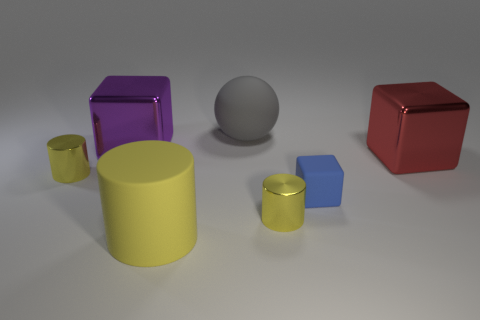Is there any pattern or theme to the arrangement of these objects? The arrangement does not immediately suggest a specific pattern or theme. The objects are placed seemingly at random, yet they are spaced out evenly, which might indicate an intentional design to display each object's properties clearly. The variety in color and shape could imply a theme of diversity or contrast, highlighting the unique characteristics of each object. 